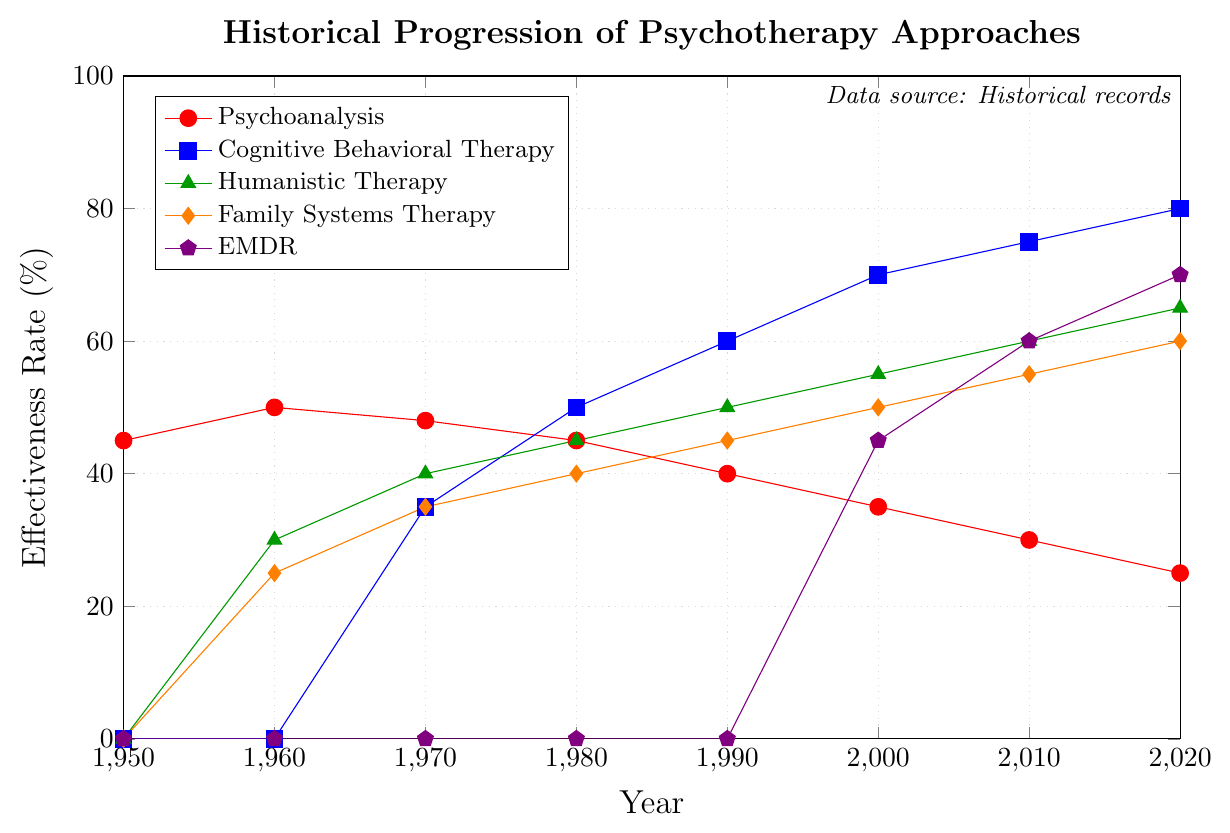What's the effectiveness rate of Cognitive Behavioral Therapy (CBT) in 1990? According to the figure, in 1990, the effectiveness rate of CBT is represented by the second plotted line from the top, which has the y-value of 60%.
Answer: 60% Which therapy approach had the highest effectiveness rate in 1980? In 1980, the figure shows that Cognitive Behavioral Therapy (CBT) had the highest effectiveness rate, with a y-value of 50%.
Answer: Cognitive Behavioral Therapy How did Humanistic Therapy's effectiveness rate change from 1960 to 2020? To determine the change, subtract the effectiveness rate in 1960 from the effectiveness rate in 2020 for Humanistic Therapy. The y-values are 65% in 2020 and 30% in 1960. Therefore, the change is 65% - 30% = 35%.
Answer: Increased by 35% What is the difference in effectiveness rates between Psychoanalysis and Cognitive Behavioral Therapy (CBT) in 2020? The effectiveness rate of Psychoanalysis in 2020 is 25%, and for CBT it is 80%. The difference is 80% - 25% = 55%.
Answer: 55% Which therapy approach experienced an effectiveness rate of 60% first, and in what year? By examining the y-values at each year, Cognitive Behavioral Therapy (CBT) reached an effectiveness rate of 60% first in 1990.
Answer: Cognitive Behavioral Therapy, 1990 Among the five therapies, which one had the second lowest effectiveness rate in 2000? In the year 2000, the effectiveness rates are: Psychoanalysis (35%), CBT (70%), Humanistic Therapy (55%), Family Systems Therapy (50%), and EMDR (45%). The second lowest is 45%, which is for EMDR.
Answer: EMDR What is the overall trend of Psychoanalysis' effectiveness rate from 1950 to 2020? From 1950 to 2020, Psychoanalysis' effectiveness rate decreases over time. It started at 45% in 1950 and reduced to 25% by 2020, showing a downward trend.
Answer: Decreasing Which therapy approach showed effectiveness rates from 0% in 1950 to 70% in 2020? According to the figure, EMDR starts at 0% in 1950 and increases to 70% in 2020.
Answer: EMDR What's the average effectiveness rate of Family Systems Therapy over all the years shown? To find the average, sum the effectiveness rates for Family Systems Therapy across all years and divide by the number of years. Summing rates: 0% + 25% + 35% + 40% + 45% + 50% + 55% + 60% = 310%, and dividing by the number of years (8): 310 / 8 = 38.75%.
Answer: 38.75% Which therapy approach shows no effectiveness rate until the year 2000? According to the figure, EMDR has an effectiveness rate of 0% from 1950 until it appears with a rate in 2000.
Answer: EMDR 